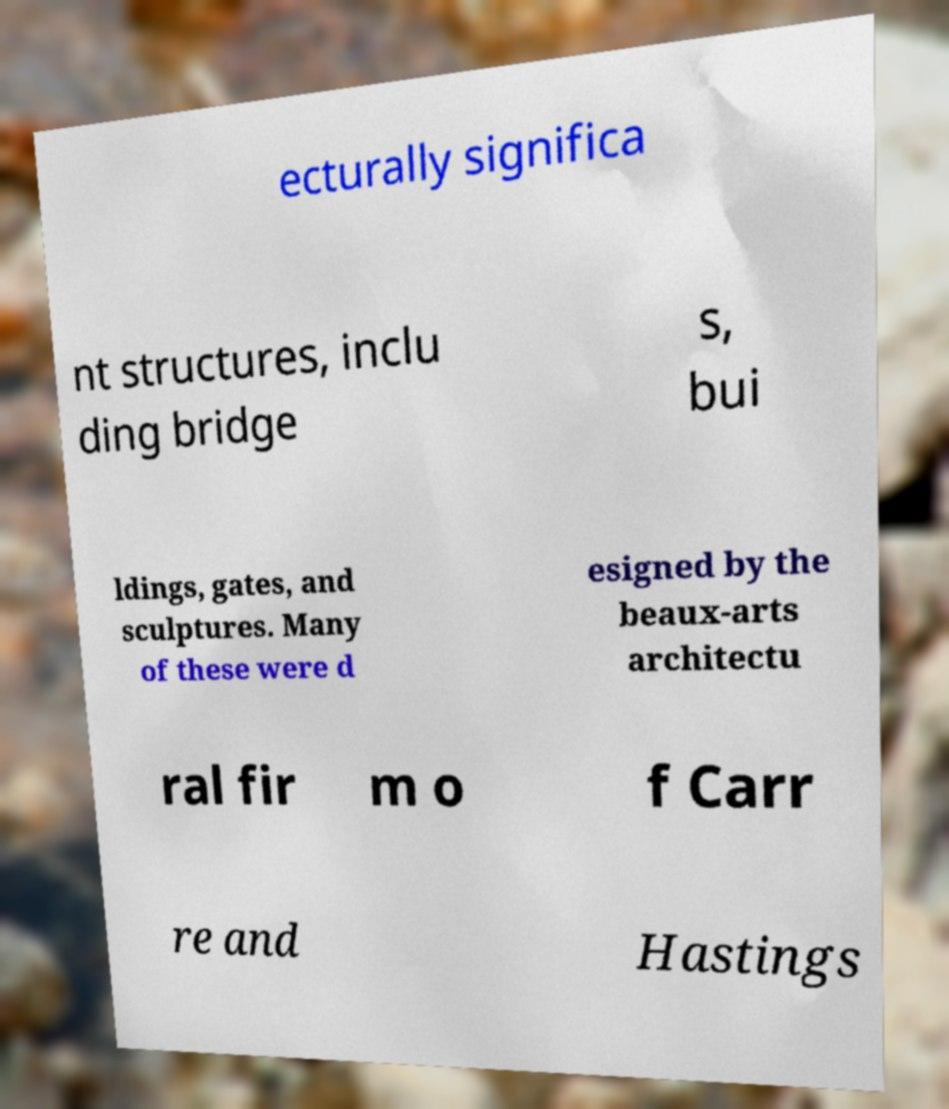Please identify and transcribe the text found in this image. ecturally significa nt structures, inclu ding bridge s, bui ldings, gates, and sculptures. Many of these were d esigned by the beaux-arts architectu ral fir m o f Carr re and Hastings 